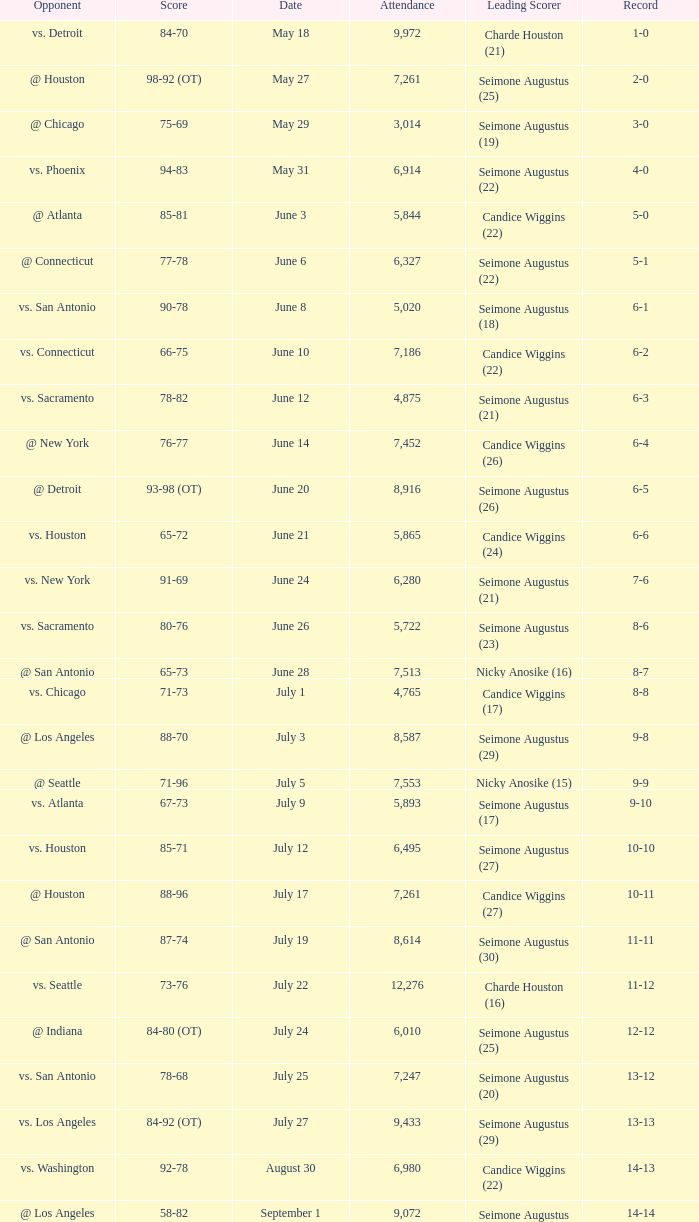Which Leading Scorer has an Opponent of @ seattle, and a Record of 14-16? Seimone Augustus (26). 